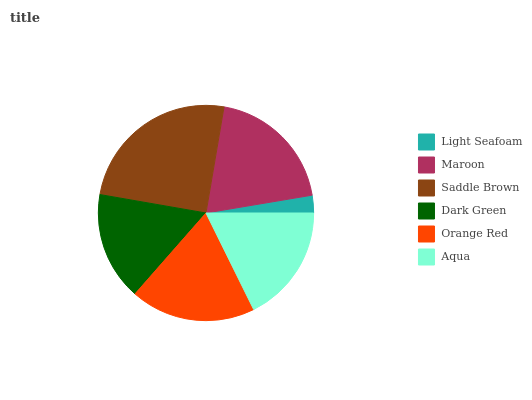Is Light Seafoam the minimum?
Answer yes or no. Yes. Is Saddle Brown the maximum?
Answer yes or no. Yes. Is Maroon the minimum?
Answer yes or no. No. Is Maroon the maximum?
Answer yes or no. No. Is Maroon greater than Light Seafoam?
Answer yes or no. Yes. Is Light Seafoam less than Maroon?
Answer yes or no. Yes. Is Light Seafoam greater than Maroon?
Answer yes or no. No. Is Maroon less than Light Seafoam?
Answer yes or no. No. Is Orange Red the high median?
Answer yes or no. Yes. Is Aqua the low median?
Answer yes or no. Yes. Is Light Seafoam the high median?
Answer yes or no. No. Is Dark Green the low median?
Answer yes or no. No. 